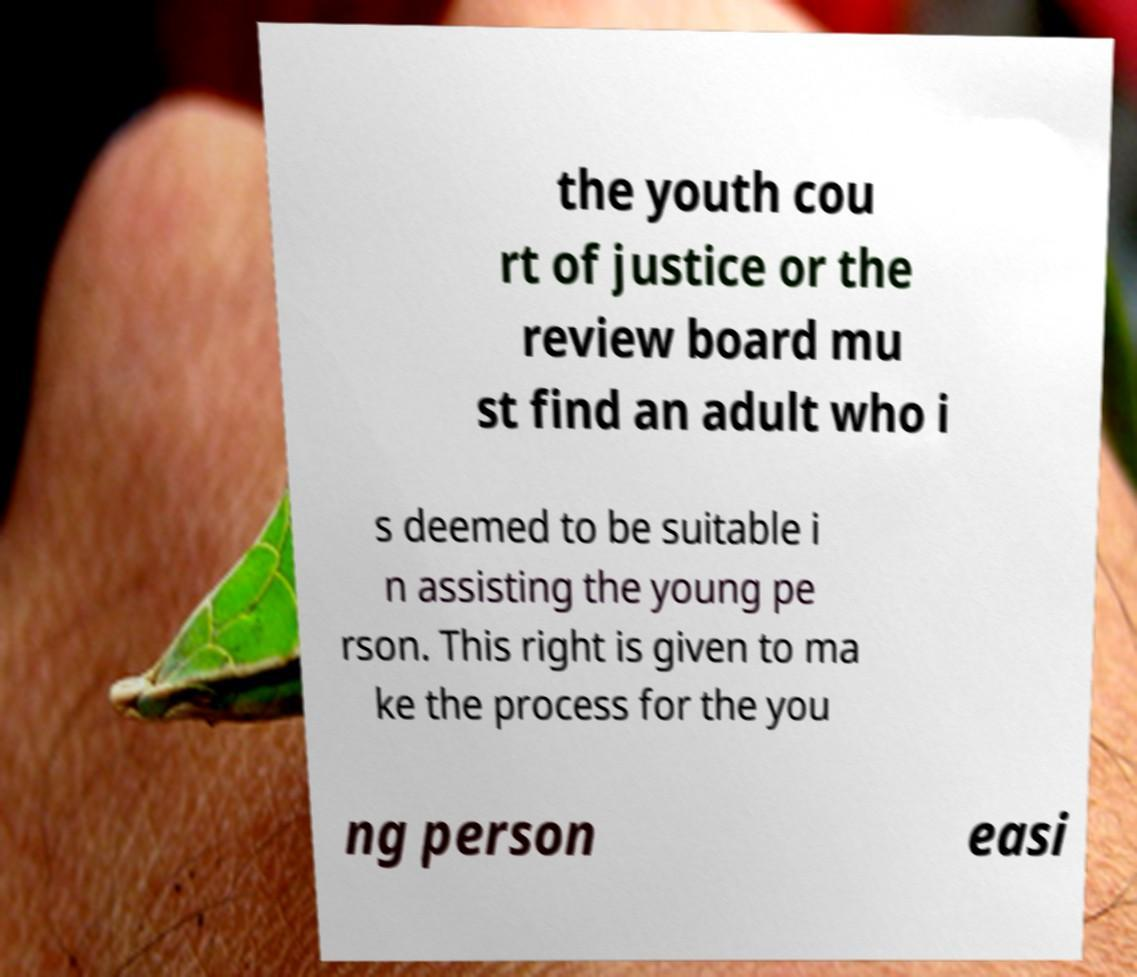Can you read and provide the text displayed in the image?This photo seems to have some interesting text. Can you extract and type it out for me? the youth cou rt of justice or the review board mu st find an adult who i s deemed to be suitable i n assisting the young pe rson. This right is given to ma ke the process for the you ng person easi 